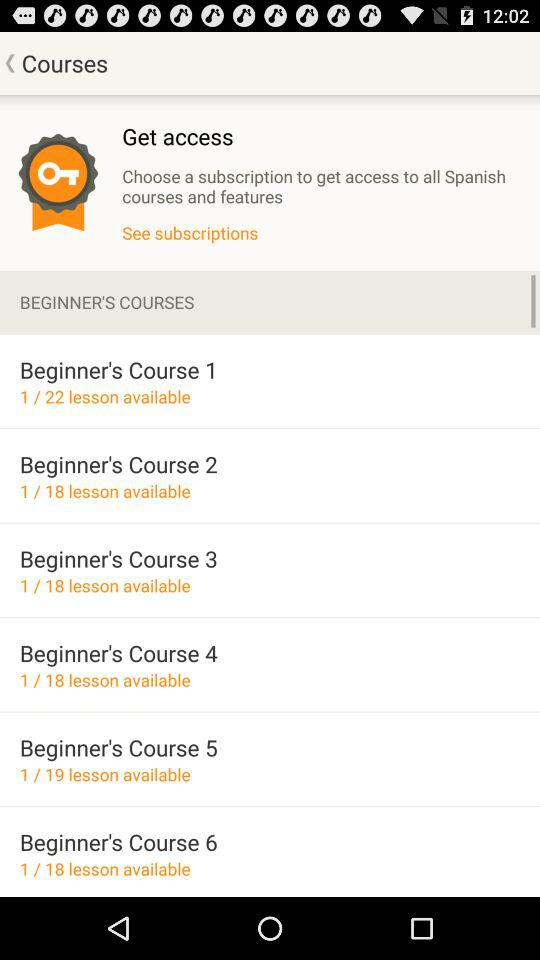How many lessons are available in the beginner's course with the most lessons?
Answer the question using a single word or phrase. 22 